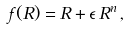Convert formula to latex. <formula><loc_0><loc_0><loc_500><loc_500>f ( R ) = R + \epsilon \, R ^ { n } \, ,</formula> 